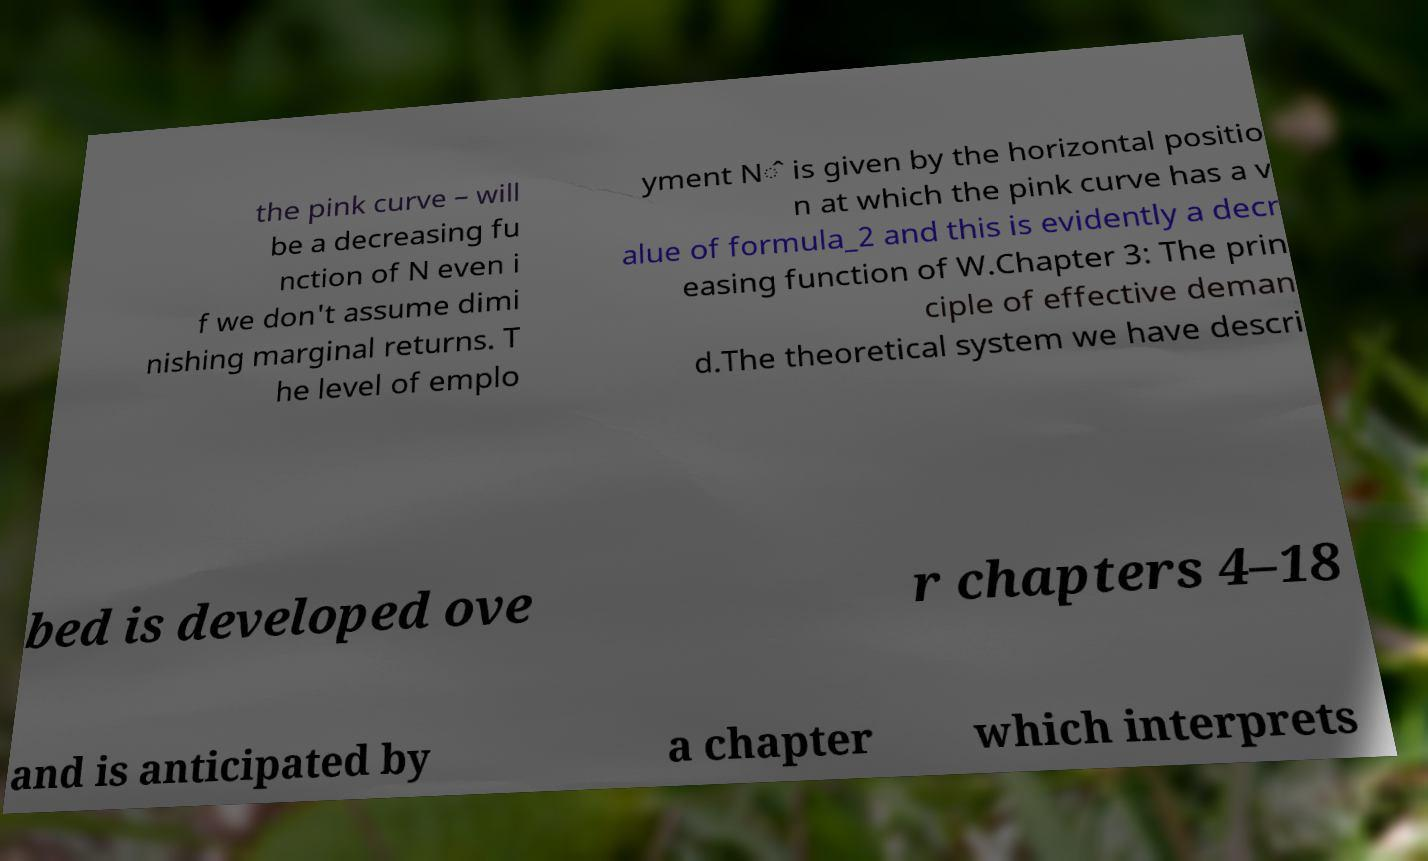For documentation purposes, I need the text within this image transcribed. Could you provide that? the pink curve – will be a decreasing fu nction of N even i f we don't assume dimi nishing marginal returns. T he level of emplo yment N̂ is given by the horizontal positio n at which the pink curve has a v alue of formula_2 and this is evidently a decr easing function of W.Chapter 3: The prin ciple of effective deman d.The theoretical system we have descri bed is developed ove r chapters 4–18 and is anticipated by a chapter which interprets 